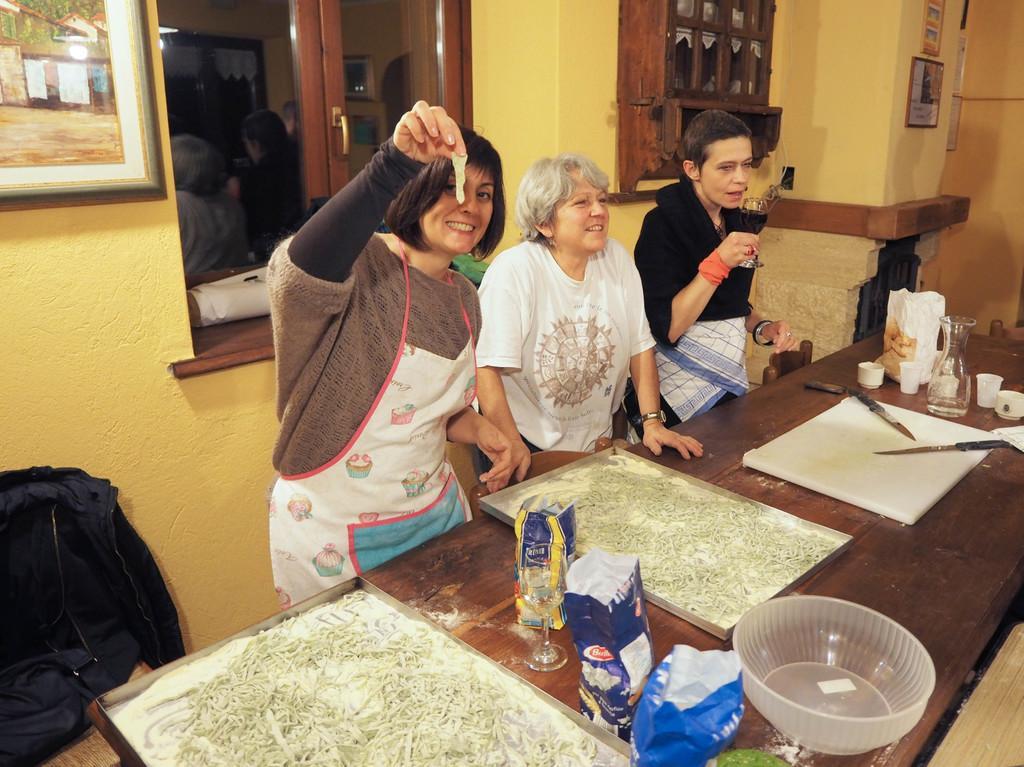How would you summarize this image in a sentence or two? There are 3 people standing at the table. On the table there is a glass jar,cups,food items and a big plate,knives,chopping pad and a bowl. In the background there is a wall,frame,window and posters on the wall. 